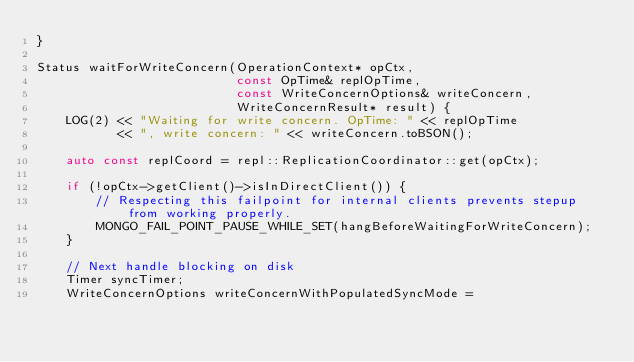Convert code to text. <code><loc_0><loc_0><loc_500><loc_500><_C++_>}

Status waitForWriteConcern(OperationContext* opCtx,
                           const OpTime& replOpTime,
                           const WriteConcernOptions& writeConcern,
                           WriteConcernResult* result) {
    LOG(2) << "Waiting for write concern. OpTime: " << replOpTime
           << ", write concern: " << writeConcern.toBSON();

    auto const replCoord = repl::ReplicationCoordinator::get(opCtx);

    if (!opCtx->getClient()->isInDirectClient()) {
        // Respecting this failpoint for internal clients prevents stepup from working properly.
        MONGO_FAIL_POINT_PAUSE_WHILE_SET(hangBeforeWaitingForWriteConcern);
    }

    // Next handle blocking on disk
    Timer syncTimer;
    WriteConcernOptions writeConcernWithPopulatedSyncMode =</code> 